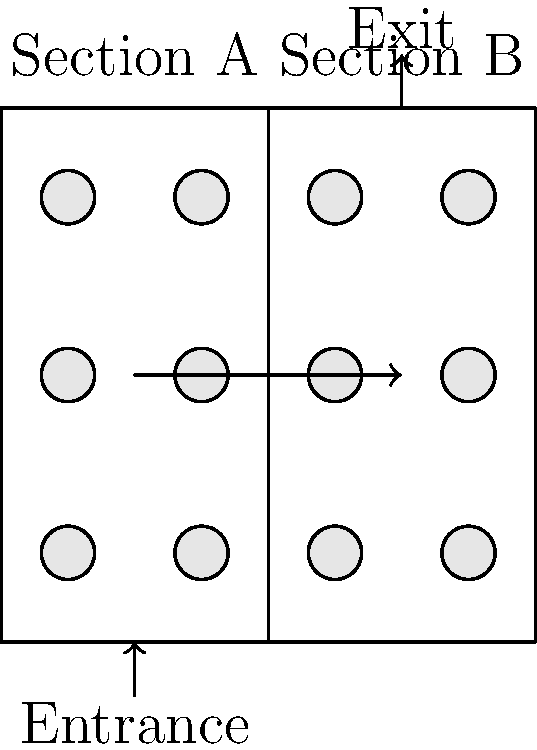During peak visiting hours at Look Memorial Park, the parking lot is divided into two sections (A and B) as shown in the diagram. If Section A can accommodate 30% more cars than Section B, and the total capacity of the parking lot is 156 cars, how many cars can be parked in Section B? Let's approach this step-by-step:

1) Let $x$ be the number of cars that can be parked in Section B.

2) Since Section A can accommodate 30% more cars than Section B, the number of cars in Section A is $1.3x$.

3) The total capacity of the parking lot is 156 cars, so we can write the equation:

   $x + 1.3x = 156$

4) Simplify the left side of the equation:

   $2.3x = 156$

5) Solve for $x$:

   $x = 156 \div 2.3 = 67.82...$

6) Since we can't park a fraction of a car, we round down to the nearest whole number.

Therefore, Section B can accommodate 67 cars.
Answer: 67 cars 